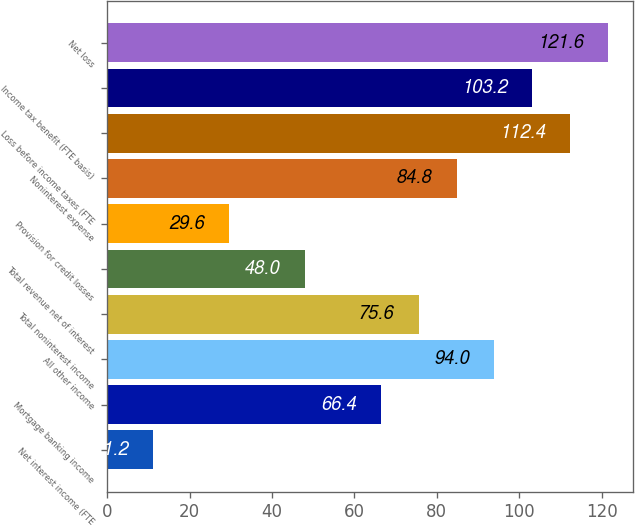<chart> <loc_0><loc_0><loc_500><loc_500><bar_chart><fcel>Net interest income (FTE<fcel>Mortgage banking income<fcel>All other income<fcel>Total noninterest income<fcel>Total revenue net of interest<fcel>Provision for credit losses<fcel>Noninterest expense<fcel>Loss before income taxes (FTE<fcel>Income tax benefit (FTE basis)<fcel>Net loss<nl><fcel>11.2<fcel>66.4<fcel>94<fcel>75.6<fcel>48<fcel>29.6<fcel>84.8<fcel>112.4<fcel>103.2<fcel>121.6<nl></chart> 